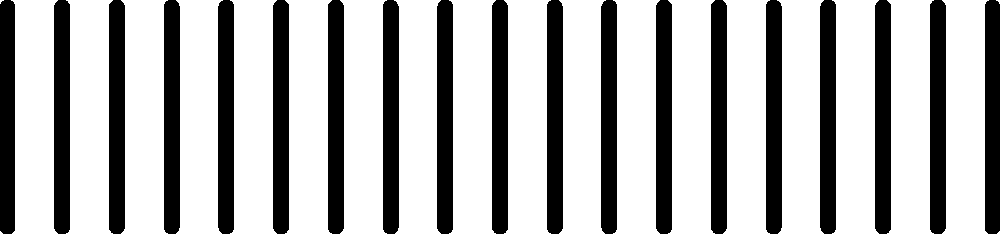In the karyotype of a domestic cat shown above, three chromosomes (A, B, and C) are highlighted. Which of these chromosomes is most likely to contain the genetic markers associated with coat color variation in felines? To answer this question, we need to consider the following steps:

1. Domestic cats have 38 chromosomes (19 pairs).

2. The highlighted chromosomes in the karyotype represent:
   A (red): Chromosome 3
   B (blue): Chromosome 6
   C (green): Chromosome 9

3. Coat color in cats is determined by several genes, but the most significant ones are:
   - The agouti gene (A)
   - The extension gene (E)
   - The dilution gene (D)
   - The piebald spotting gene (S)

4. Among these genes:
   - The agouti (A) gene is located on chromosome 3
   - The extension (E) gene is located on chromosome 3
   - The dilution (D) gene is located on chromosome D1
   - The piebald spotting (S) gene is located on chromosome A1

5. Chromosome 3 (highlighted in red and labeled A in the karyotype) contains two of the most important genes for coat color variation: agouti (A) and extension (E).

6. Therefore, chromosome A (red) is most likely to contain the genetic markers associated with coat color variation in felines.
Answer: Chromosome A (red) 